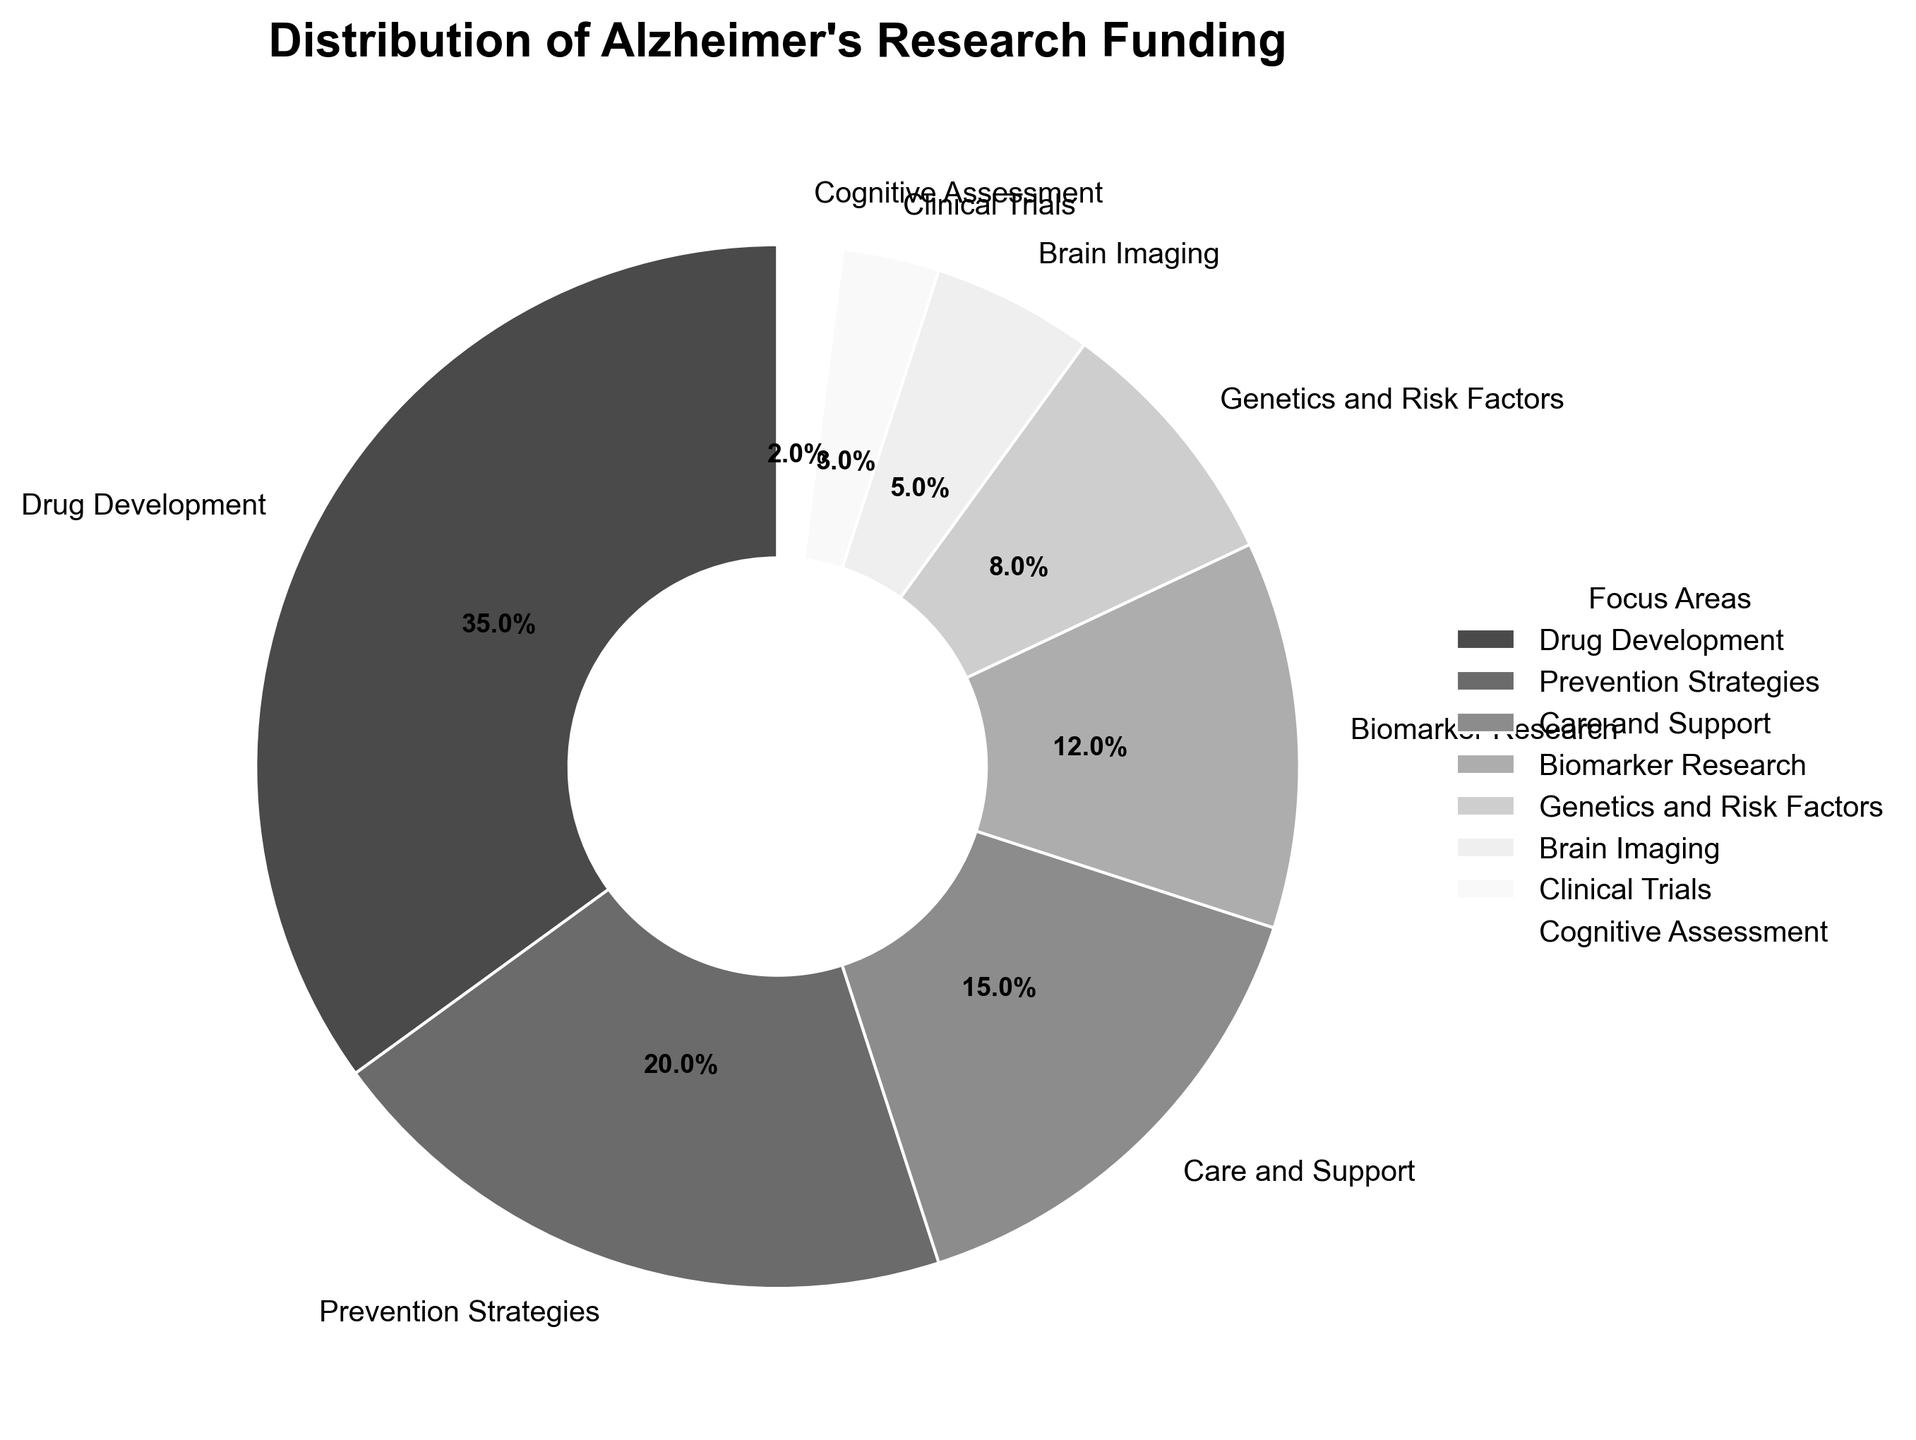Which focus area receives the highest percentage of funding? The focus area with the highest percentage can be identified by finding the largest segment in the pie chart. The segment for "Drug Development" is the largest at 35%.
Answer: Drug Development Which focus area receives the least percentage of funding? The focus area with the smallest percentage can be identified by finding the smallest segment in the pie chart. The segment for "Cognitive Assessment" is the smallest at 2%.
Answer: Cognitive Assessment What is the combined percentage of funding for Biomarker Research and Genetics and Risk Factors? Add the percentages of the two focus areas, Biomarker Research (12%) and Genetics and Risk Factors (8%). The combined percentage is 12% + 8% = 20%.
Answer: 20% Is the funding for Care and Support higher or lower than Prevention Strategies? Compare the percentages for Care and Support (15%) and Prevention Strategies (20%). The funding for Care and Support is lower than that for Prevention Strategies.
Answer: Lower Which focus areas have a funding percentage greater than Brain Imaging? Identify the focus areas with a percentage higher than Brain Imaging's 5%. These are Drug Development (35%), Prevention Strategies (20%), Care and Support (15%), Biomarker Research (12%), and Genetics and Risk Factors (8%).
Answer: Drug Development, Prevention Strategies, Care and Support, Biomarker Research, Genetics and Risk Factors What percentage of the funding does Clinical Trials receive compared to Cognitive Assessment? Compare the percentages for Clinical Trials (3%) and Cognitive Assessment (2%) by calculating the ratio. Clinical Trials receive 3%/2% = 1.5 times the funding of Cognitive Assessment.
Answer: 1.5 times How much higher is the percentage for Drug Development than for Brain Imaging? Subtract the percentage of Brain Imaging (5%) from the percentage of Drug Development (35%). 35% - 5% = 30%.
Answer: 30% What is the average percentage of funding for the top three focus areas? The top three focus areas are Drug Development (35%), Prevention Strategies (20%), and Care and Support (15%). The average is calculated as (35% + 20% + 15%) / 3 = 70% / 3 ≈ 23.3%.
Answer: 23.3% 